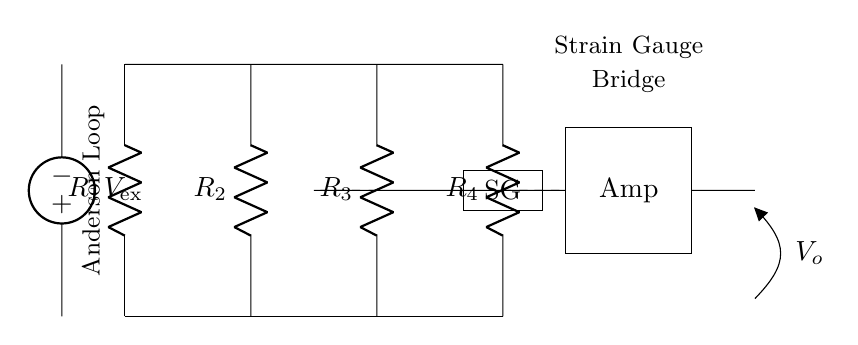What is the purpose of the voltage source in this circuit? The voltage source provides the excitation voltage necessary for the operation of the strain gauge, supplying current to the bridge circuit.
Answer: Excitation voltage What type of circuit is this? This is a Wheatstone bridge circuit designed for measuring resistance changes due to strain in a gauge.
Answer: Wheatstone bridge How many resistors are present in this circuit? There are four resistors in the Anderson loop bridge circuit, labeled R1, R2, R3, and R4.
Answer: Four What does "SG" represent in the circuit? "SG" represents the strain gauge, which changes resistance as it experiences strain, thus affecting the overall balance of the bridge circuit.
Answer: Strain gauge What is the significance of the amplifier in this circuit? The amplifier boosts the output voltage from the bridge circuit to a level that is readable by measurement devices, allowing for precise strain measurement.
Answer: Boosts output What could happen if R1 equals R4 and R2 equals R3? If R1 equals R4 and R2 equals R3, the bridge would be balanced, resulting in zero output voltage, indicating no strain detected.
Answer: Zero output voltage 